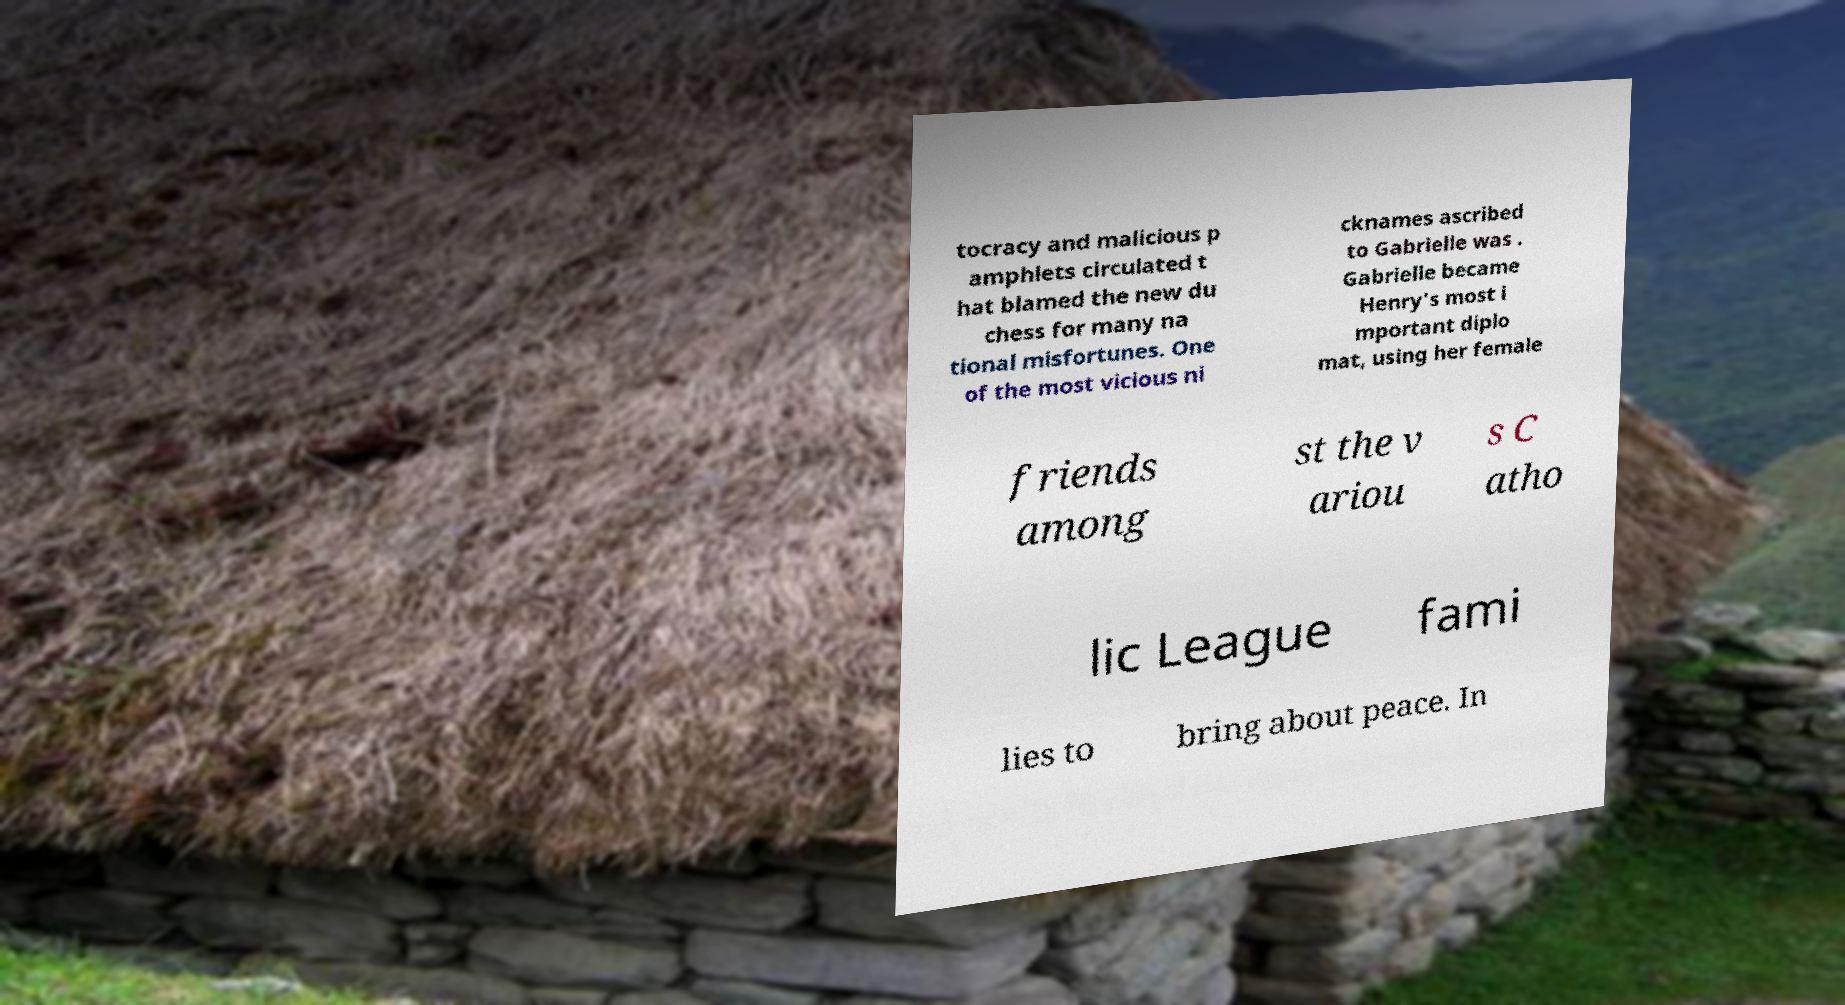For documentation purposes, I need the text within this image transcribed. Could you provide that? tocracy and malicious p amphlets circulated t hat blamed the new du chess for many na tional misfortunes. One of the most vicious ni cknames ascribed to Gabrielle was . Gabrielle became Henry's most i mportant diplo mat, using her female friends among st the v ariou s C atho lic League fami lies to bring about peace. In 